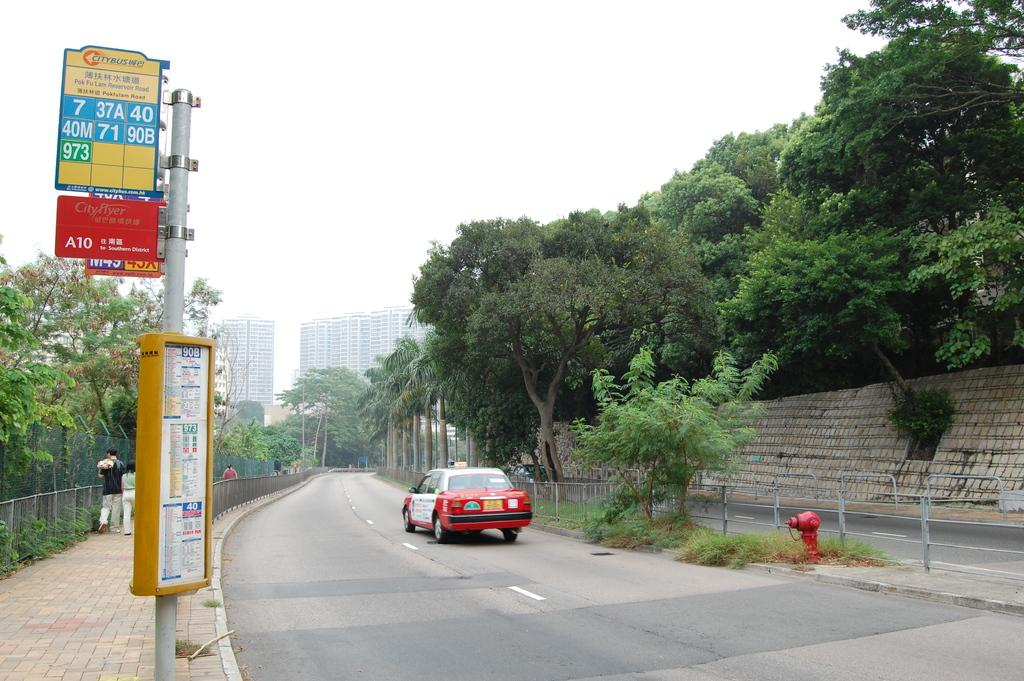<image>
Render a clear and concise summary of the photo. The Citybus schedule is listed on the pole on the side of the road. 